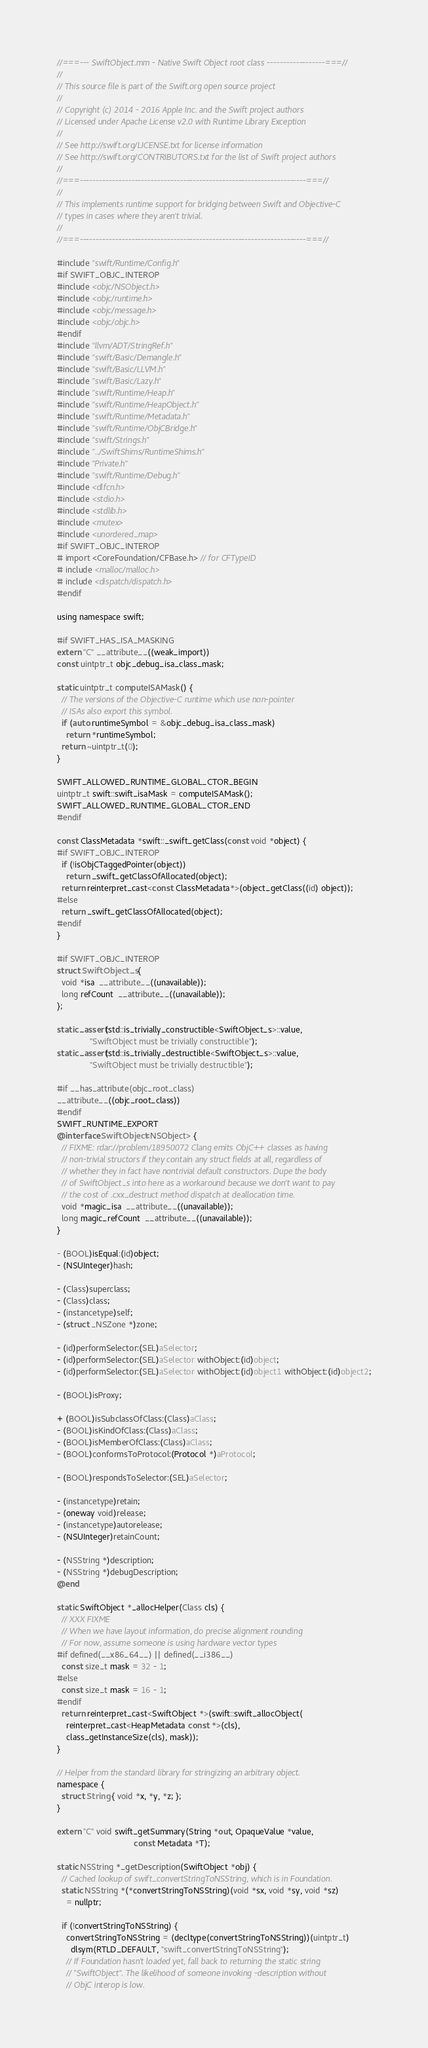<code> <loc_0><loc_0><loc_500><loc_500><_ObjectiveC_>//===--- SwiftObject.mm - Native Swift Object root class ------------------===//
//
// This source file is part of the Swift.org open source project
//
// Copyright (c) 2014 - 2016 Apple Inc. and the Swift project authors
// Licensed under Apache License v2.0 with Runtime Library Exception
//
// See http://swift.org/LICENSE.txt for license information
// See http://swift.org/CONTRIBUTORS.txt for the list of Swift project authors
//
//===----------------------------------------------------------------------===//
//
// This implements runtime support for bridging between Swift and Objective-C
// types in cases where they aren't trivial.
//
//===----------------------------------------------------------------------===//

#include "swift/Runtime/Config.h"
#if SWIFT_OBJC_INTEROP
#include <objc/NSObject.h>
#include <objc/runtime.h>
#include <objc/message.h>
#include <objc/objc.h>
#endif
#include "llvm/ADT/StringRef.h"
#include "swift/Basic/Demangle.h"
#include "swift/Basic/LLVM.h"
#include "swift/Basic/Lazy.h"
#include "swift/Runtime/Heap.h"
#include "swift/Runtime/HeapObject.h"
#include "swift/Runtime/Metadata.h"
#include "swift/Runtime/ObjCBridge.h"
#include "swift/Strings.h"
#include "../SwiftShims/RuntimeShims.h"
#include "Private.h"
#include "swift/Runtime/Debug.h"
#include <dlfcn.h>
#include <stdio.h>
#include <stdlib.h>
#include <mutex>
#include <unordered_map>
#if SWIFT_OBJC_INTEROP
# import <CoreFoundation/CFBase.h> // for CFTypeID
# include <malloc/malloc.h>
# include <dispatch/dispatch.h>
#endif

using namespace swift;

#if SWIFT_HAS_ISA_MASKING
extern "C" __attribute__((weak_import))
const uintptr_t objc_debug_isa_class_mask;

static uintptr_t computeISAMask() {
  // The versions of the Objective-C runtime which use non-pointer
  // ISAs also export this symbol.
  if (auto runtimeSymbol = &objc_debug_isa_class_mask)
    return *runtimeSymbol;
  return ~uintptr_t(0);
}

SWIFT_ALLOWED_RUNTIME_GLOBAL_CTOR_BEGIN
uintptr_t swift::swift_isaMask = computeISAMask();
SWIFT_ALLOWED_RUNTIME_GLOBAL_CTOR_END
#endif

const ClassMetadata *swift::_swift_getClass(const void *object) {
#if SWIFT_OBJC_INTEROP
  if (!isObjCTaggedPointer(object))
    return _swift_getClassOfAllocated(object);
  return reinterpret_cast<const ClassMetadata*>(object_getClass((id) object));
#else
  return _swift_getClassOfAllocated(object);
#endif
}

#if SWIFT_OBJC_INTEROP
struct SwiftObject_s {
  void *isa  __attribute__((unavailable));
  long refCount  __attribute__((unavailable));
};

static_assert(std::is_trivially_constructible<SwiftObject_s>::value,
              "SwiftObject must be trivially constructible");
static_assert(std::is_trivially_destructible<SwiftObject_s>::value,
              "SwiftObject must be trivially destructible");

#if __has_attribute(objc_root_class)
__attribute__((objc_root_class))
#endif
SWIFT_RUNTIME_EXPORT
@interface SwiftObject<NSObject> {
  // FIXME: rdar://problem/18950072 Clang emits ObjC++ classes as having
  // non-trivial structors if they contain any struct fields at all, regardless of
  // whether they in fact have nontrivial default constructors. Dupe the body
  // of SwiftObject_s into here as a workaround because we don't want to pay
  // the cost of .cxx_destruct method dispatch at deallocation time.
  void *magic_isa  __attribute__((unavailable));
  long magic_refCount  __attribute__((unavailable));
}

- (BOOL)isEqual:(id)object;
- (NSUInteger)hash;

- (Class)superclass;
- (Class)class;
- (instancetype)self;
- (struct _NSZone *)zone;

- (id)performSelector:(SEL)aSelector;
- (id)performSelector:(SEL)aSelector withObject:(id)object;
- (id)performSelector:(SEL)aSelector withObject:(id)object1 withObject:(id)object2;

- (BOOL)isProxy;

+ (BOOL)isSubclassOfClass:(Class)aClass;
- (BOOL)isKindOfClass:(Class)aClass;
- (BOOL)isMemberOfClass:(Class)aClass;
- (BOOL)conformsToProtocol:(Protocol *)aProtocol;

- (BOOL)respondsToSelector:(SEL)aSelector;

- (instancetype)retain;
- (oneway void)release;
- (instancetype)autorelease;
- (NSUInteger)retainCount;

- (NSString *)description;
- (NSString *)debugDescription;
@end

static SwiftObject *_allocHelper(Class cls) {
  // XXX FIXME
  // When we have layout information, do precise alignment rounding
  // For now, assume someone is using hardware vector types
#if defined(__x86_64__) || defined(__i386__)
  const size_t mask = 32 - 1;
#else
  const size_t mask = 16 - 1;
#endif
  return reinterpret_cast<SwiftObject *>(swift::swift_allocObject(
    reinterpret_cast<HeapMetadata const *>(cls),
    class_getInstanceSize(cls), mask));
}

// Helper from the standard library for stringizing an arbitrary object.
namespace {
  struct String { void *x, *y, *z; };
}

extern "C" void swift_getSummary(String *out, OpaqueValue *value,
                                 const Metadata *T);

static NSString *_getDescription(SwiftObject *obj) {
  // Cached lookup of swift_convertStringToNSString, which is in Foundation.
  static NSString *(*convertStringToNSString)(void *sx, void *sy, void *sz)
    = nullptr;
  
  if (!convertStringToNSString) {
    convertStringToNSString = (decltype(convertStringToNSString))(uintptr_t)
      dlsym(RTLD_DEFAULT, "swift_convertStringToNSString");
    // If Foundation hasn't loaded yet, fall back to returning the static string
    // "SwiftObject". The likelihood of someone invoking -description without
    // ObjC interop is low.</code> 